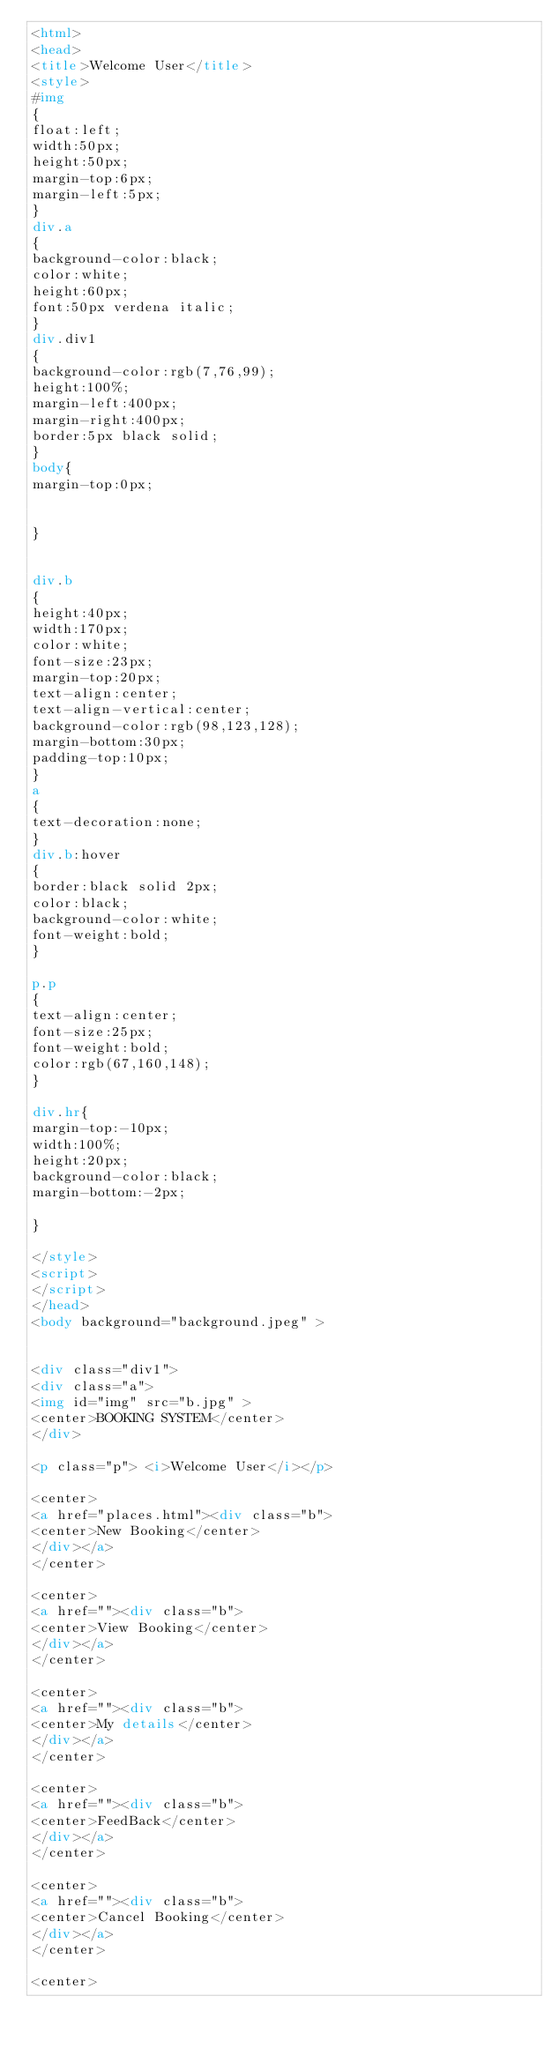<code> <loc_0><loc_0><loc_500><loc_500><_HTML_><html>
<head>
<title>Welcome User</title>
<style>
#img
{
float:left;
width:50px;
height:50px;
margin-top:6px;
margin-left:5px;
}
div.a
{
background-color:black;
color:white;
height:60px;
font:50px verdena italic;
}
div.div1
{
background-color:rgb(7,76,99);
height:100%;
margin-left:400px;
margin-right:400px;
border:5px black solid;
}
body{
margin-top:0px;


}


div.b
{
height:40px;
width:170px;
color:white;
font-size:23px;
margin-top:20px;
text-align:center;
text-align-vertical:center;
background-color:rgb(98,123,128);
margin-bottom:30px;
padding-top:10px;
}
a
{
text-decoration:none;
}
div.b:hover
{
border:black solid 2px;
color:black;
background-color:white;
font-weight:bold;
}

p.p
{
text-align:center;
font-size:25px;
font-weight:bold;
color:rgb(67,160,148);
}

div.hr{
margin-top:-10px;
width:100%;
height:20px;
background-color:black;
margin-bottom:-2px;

}

</style>
<script>
</script>
</head>
<body background="background.jpeg" >


<div class="div1">
<div class="a">
<img id="img" src="b.jpg" >
<center>BOOKING SYSTEM</center>
</div>

<p class="p"> <i>Welcome User</i></p>

<center>
<a href="places.html"><div class="b">
<center>New Booking</center>
</div></a>
</center>

<center>
<a href=""><div class="b">
<center>View Booking</center>
</div></a>
</center>

<center>
<a href=""><div class="b">
<center>My details</center>
</div></a>
</center>

<center>
<a href=""><div class="b">
<center>FeedBack</center>
</div></a>
</center>

<center>
<a href=""><div class="b">
<center>Cancel Booking</center>
</div></a>
</center>

<center></code> 